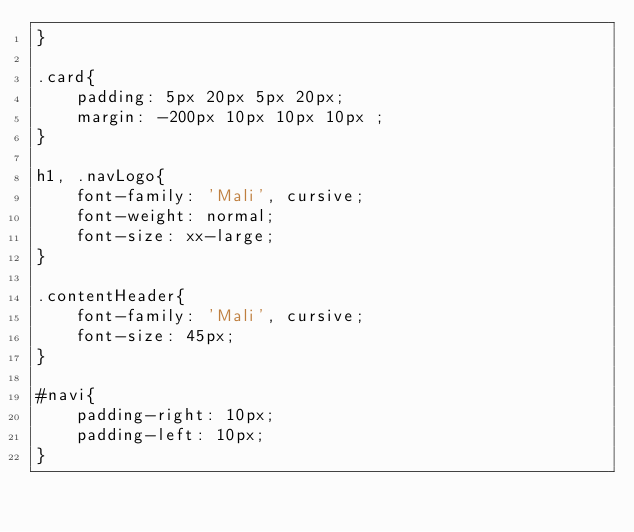Convert code to text. <code><loc_0><loc_0><loc_500><loc_500><_CSS_>}

.card{
    padding: 5px 20px 5px 20px;
    margin: -200px 10px 10px 10px ;
}

h1, .navLogo{
    font-family: 'Mali', cursive;
    font-weight: normal;
    font-size: xx-large;
}

.contentHeader{
    font-family: 'Mali', cursive;
    font-size: 45px;
}

#navi{
    padding-right: 10px;
    padding-left: 10px;
}</code> 